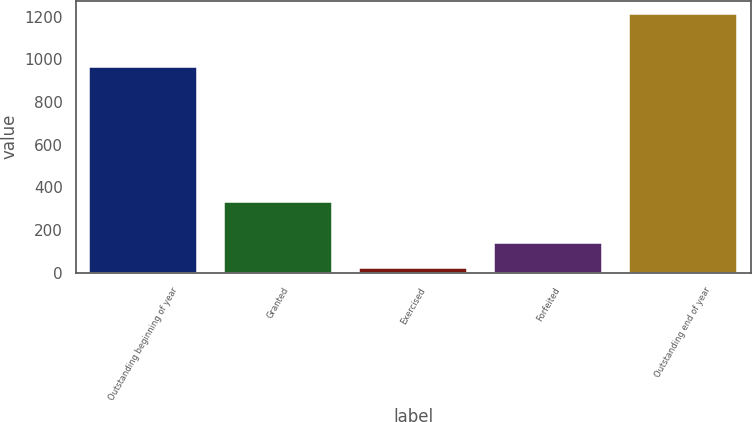Convert chart to OTSL. <chart><loc_0><loc_0><loc_500><loc_500><bar_chart><fcel>Outstanding beginning of year<fcel>Granted<fcel>Exercised<fcel>Forfeited<fcel>Outstanding end of year<nl><fcel>965<fcel>332<fcel>22<fcel>141.2<fcel>1214<nl></chart> 